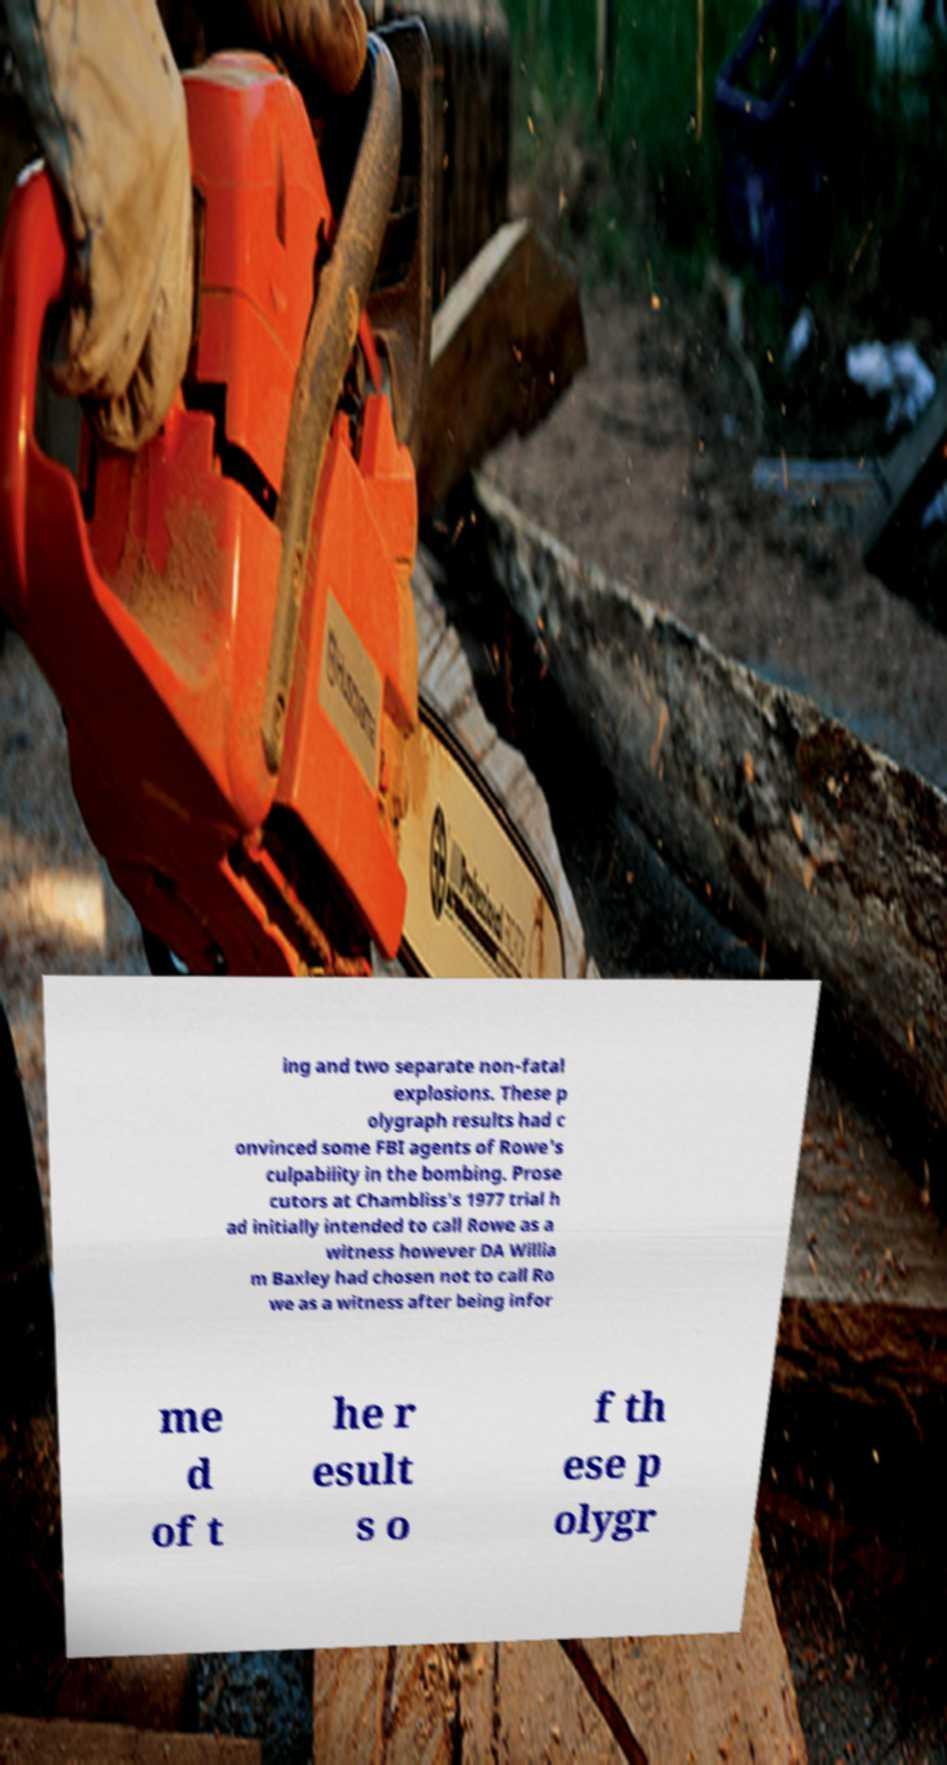Could you extract and type out the text from this image? ing and two separate non-fatal explosions. These p olygraph results had c onvinced some FBI agents of Rowe's culpability in the bombing. Prose cutors at Chambliss's 1977 trial h ad initially intended to call Rowe as a witness however DA Willia m Baxley had chosen not to call Ro we as a witness after being infor me d of t he r esult s o f th ese p olygr 